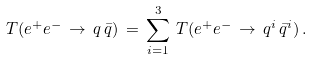Convert formula to latex. <formula><loc_0><loc_0><loc_500><loc_500>T ( e ^ { + } e ^ { - } \, \rightarrow \, q \, \bar { q } ) \, = \, \sum _ { i = 1 } ^ { 3 } \, T ( e ^ { + } e ^ { - } \, \rightarrow \, q ^ { i } \, \bar { q } ^ { i } ) \, .</formula> 